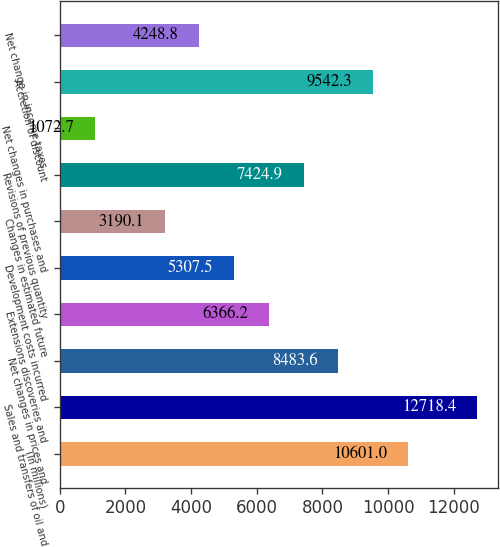Convert chart to OTSL. <chart><loc_0><loc_0><loc_500><loc_500><bar_chart><fcel>(In millions)<fcel>Sales and transfers of oil and<fcel>Net changes in prices and<fcel>Extensions discoveries and<fcel>Development costs incurred<fcel>Changes in estimated future<fcel>Revisions of previous quantity<fcel>Net changes in purchases and<fcel>Accretion of discount<fcel>Net change in income taxes<nl><fcel>10601<fcel>12718.4<fcel>8483.6<fcel>6366.2<fcel>5307.5<fcel>3190.1<fcel>7424.9<fcel>1072.7<fcel>9542.3<fcel>4248.8<nl></chart> 